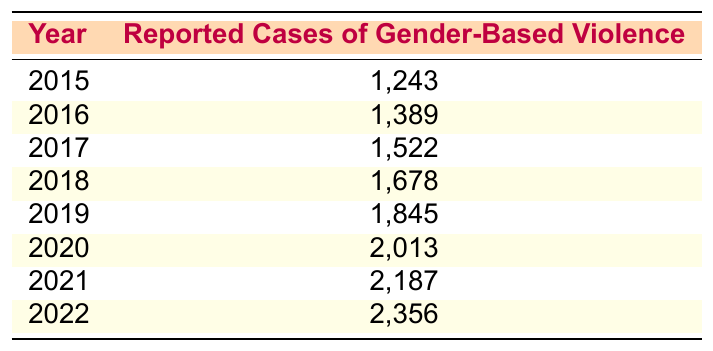What was the reported case of gender-based violence in 2015? According to the table, in the year 2015, there were 1,243 reported cases of gender-based violence.
Answer: 1,243 Which year had the highest reported cases of gender-based violence? The highest number of reported cases in the table is found in the year 2022, with 2,356 cases.
Answer: 2022 What is the increase in reported cases from 2015 to 2022? To find the increase, subtract the cases in 2015 (1,243) from the cases in 2022 (2,356). This gives us 2,356 - 1,243 = 1,113.
Answer: 1,113 How many cases were reported in 2019? The table shows that in 2019, there were 1,845 reported cases of gender-based violence.
Answer: 1,845 What is the average number of reported cases from 2015 to 2022? To calculate the average, first sum the cases from 2015 to 2022: 1,243 + 1,389 + 1,522 + 1,678 + 1,845 + 2,013 + 2,187 + 2,356 = 12,233. Then divide by the number of years (8), which is 12,233 / 8 = 1,529.125.
Answer: 1,529.125 Is the number of reported cases in 2020 greater than in 2018? Yes, the reported cases in 2020 (2,013) are greater than those in 2018 (1,678).
Answer: Yes What is the total reported cases of gender-based violence from 2016 to 2018? To find the total, sum the reported cases for the years 2016 (1,389), 2017 (1,522), and 2018 (1,678): 1,389 + 1,522 + 1,678 = 4,589.
Answer: 4,589 What percentage increase in reported cases occurred from 2015 to 2021? First, calculate the increase from 2015 (1,243) to 2021 (2,187), which is 2,187 - 1,243 = 944. Then divide the increase (944) by the original number (1,243) and multiply by 100 to get the percentage: (944 / 1,243) * 100 ≈ 76%.
Answer: 76% How does the reported case for 2022 compare to 2015? The cases reported in 2022 (2,356) are significantly higher than those reported in 2015 (1,243), indicating a rising trend over the years.
Answer: Higher 